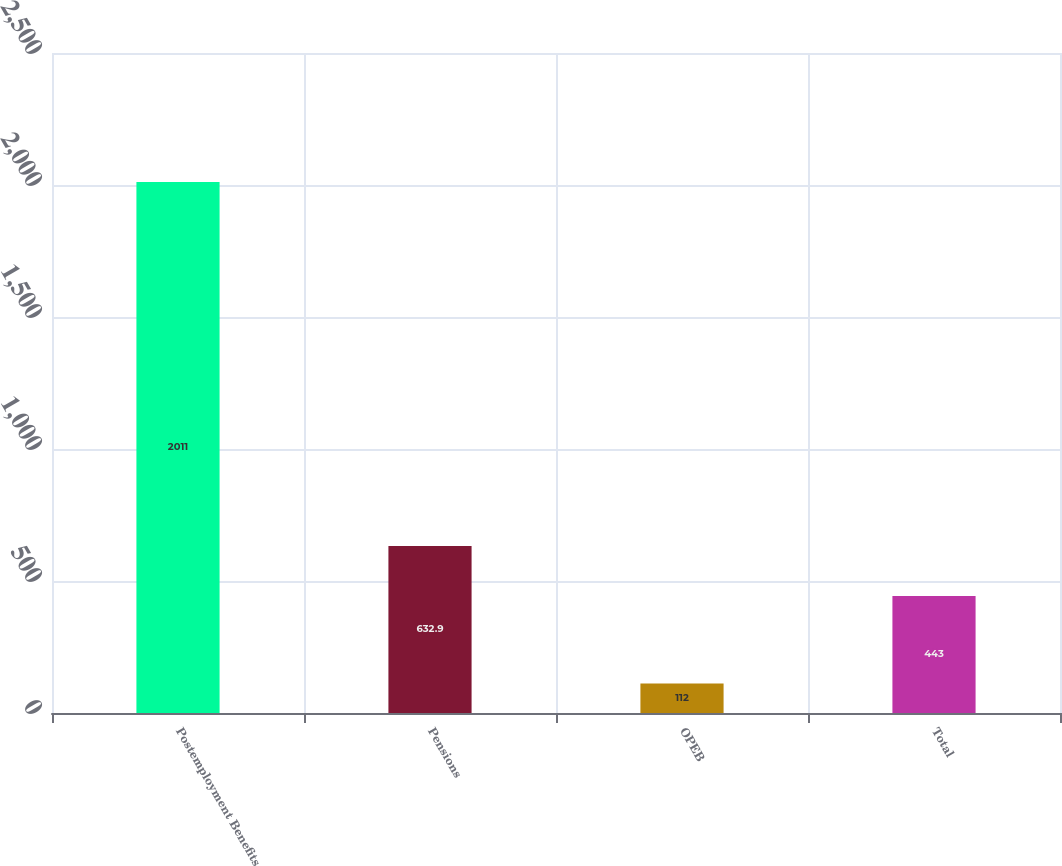Convert chart. <chart><loc_0><loc_0><loc_500><loc_500><bar_chart><fcel>Postemployment Benefits<fcel>Pensions<fcel>OPEB<fcel>Total<nl><fcel>2011<fcel>632.9<fcel>112<fcel>443<nl></chart> 